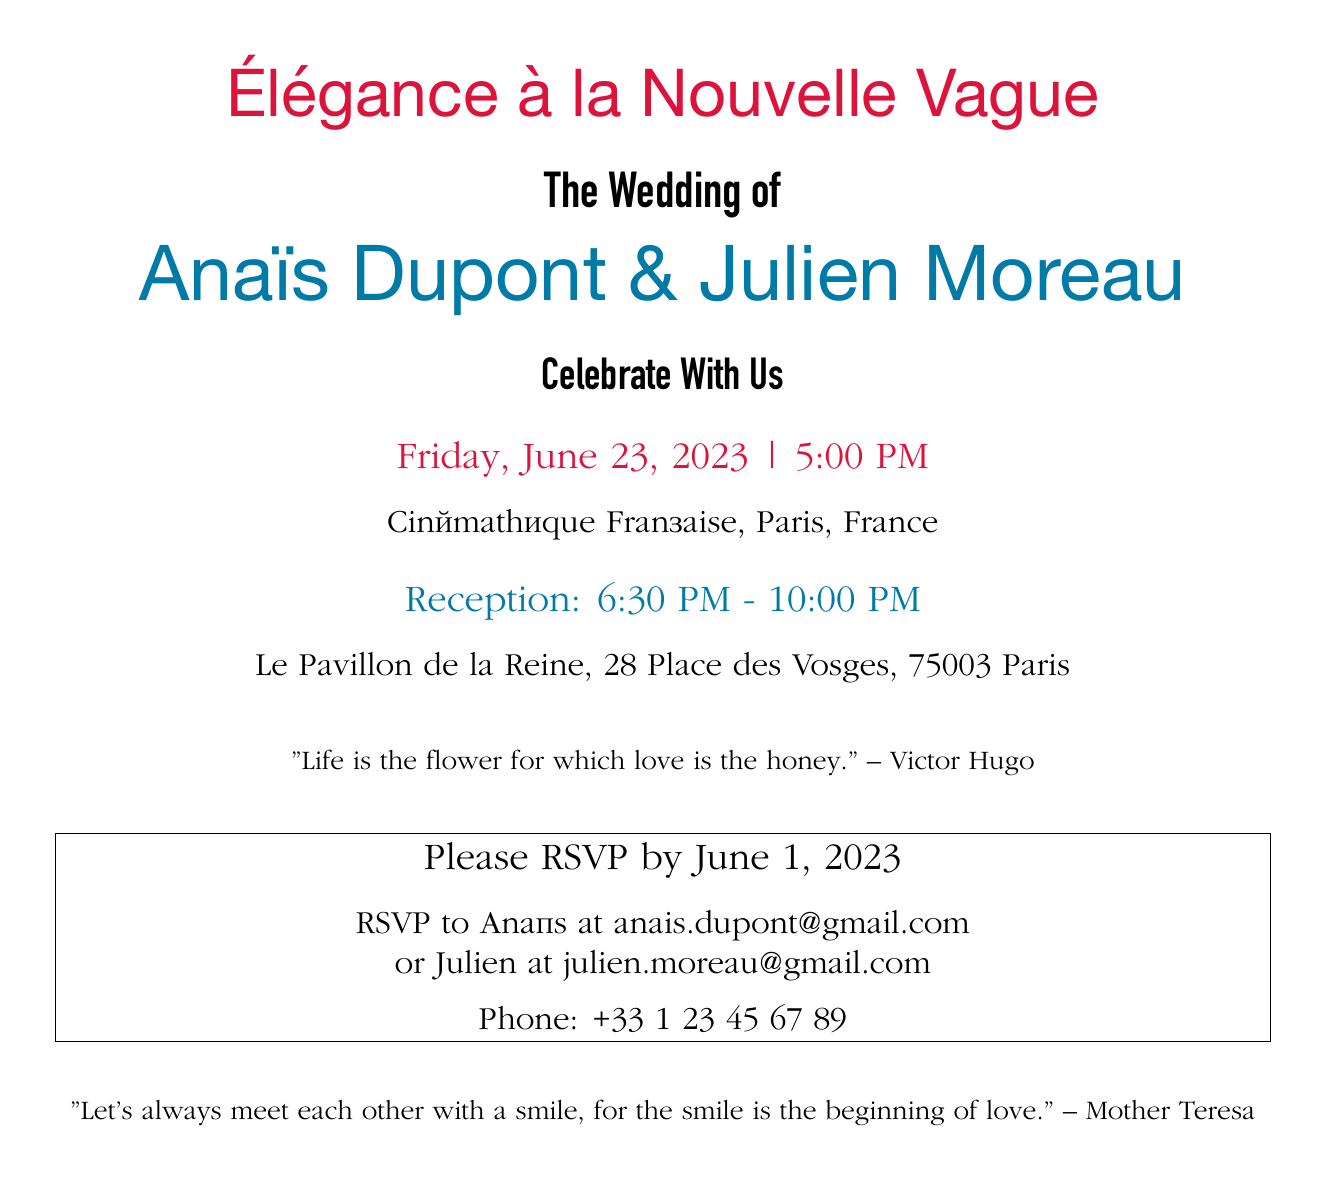What is the title of the invitation? The title of the invitation is prominently displayed at the top of the document in a larger font size.
Answer: Élégance à la Nouvelle Vague Who are the couple getting married? The names of the couple are clearly stated in a larger font, which draws attention to them.
Answer: Anaïs Dupont & Julien Moreau What is the date of the wedding? The date is specified in the middle section of the invitation, indicating when the event will occur.
Answer: Friday, June 23, 2023 Where is the wedding ceremony taking place? The location of the wedding ceremony is mentioned below the date, specifying the venue.
Answer: Cinémathèque Française, Paris, France What time does the reception start? The reception time is listed separately after the ceremony details, indicating when the guests should arrive for the reception.
Answer: 6:30 PM What quote is included on the invitation? There is a literary quote included, which adds a poetic touch to the invitation.
Answer: "Life is the flower for which love is the honey." – Victor Hugo What is the RSVP deadline? The invitation specifies a clear date for guests to respond, which is essential for planning purposes.
Answer: June 1, 2023 What colors are used in the design? The invitation features specific colors that contribute to its aesthetic, mentioned in the title and throughout the document.
Answer: Crimson and Cerulean What kind of font is used for the main text? The type of font for the main text is indicated in the document's code, revealing the design choices made for typography.
Answer: Garamond 